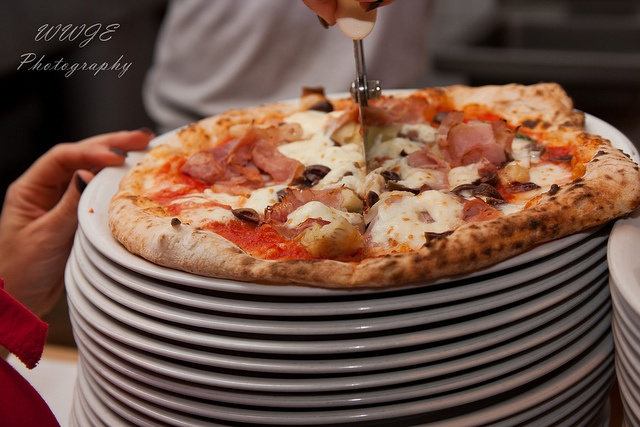Describe the objects in this image and their specific colors. I can see pizza in black, brown, tan, and maroon tones, people in black, gray, and maroon tones, people in black, maroon, and brown tones, and knife in black, maroon, and gray tones in this image. 